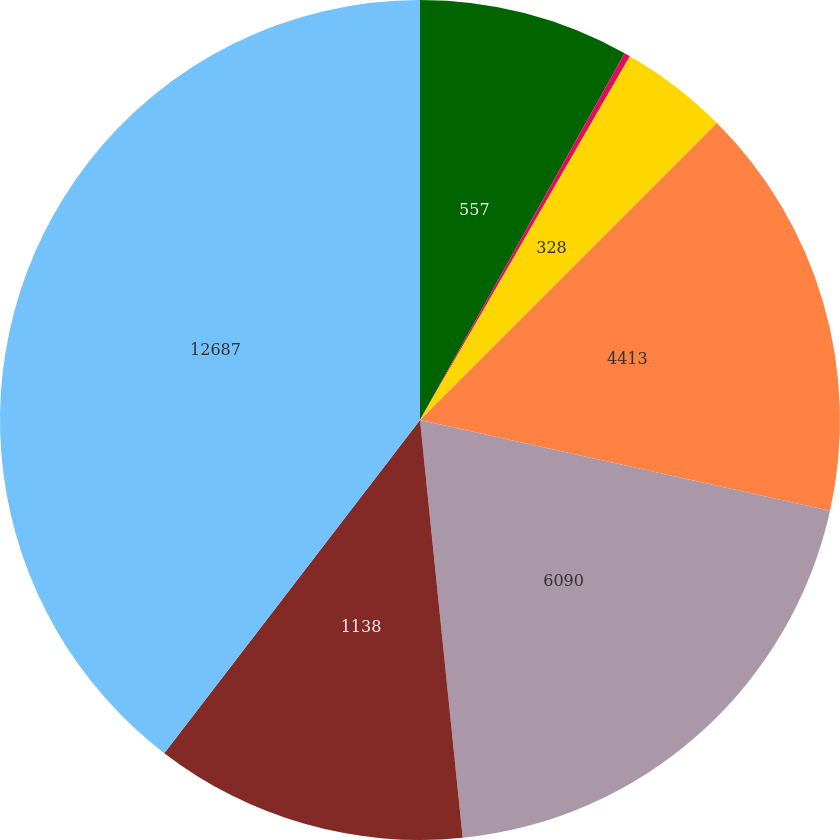Convert chart. <chart><loc_0><loc_0><loc_500><loc_500><pie_chart><fcel>557<fcel>127<fcel>328<fcel>4413<fcel>6090<fcel>1138<fcel>12687<nl><fcel>8.1%<fcel>0.23%<fcel>4.17%<fcel>15.97%<fcel>19.91%<fcel>12.04%<fcel>39.58%<nl></chart> 